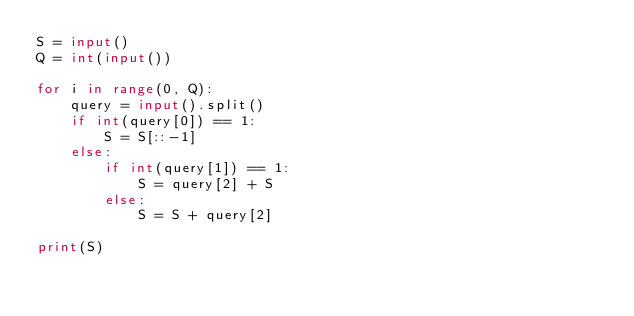Convert code to text. <code><loc_0><loc_0><loc_500><loc_500><_Python_>S = input()
Q = int(input())

for i in range(0, Q):
    query = input().split()
    if int(query[0]) == 1:
        S = S[::-1]
    else:
        if int(query[1]) == 1:
            S = query[2] + S
        else:
            S = S + query[2]

print(S)
</code> 